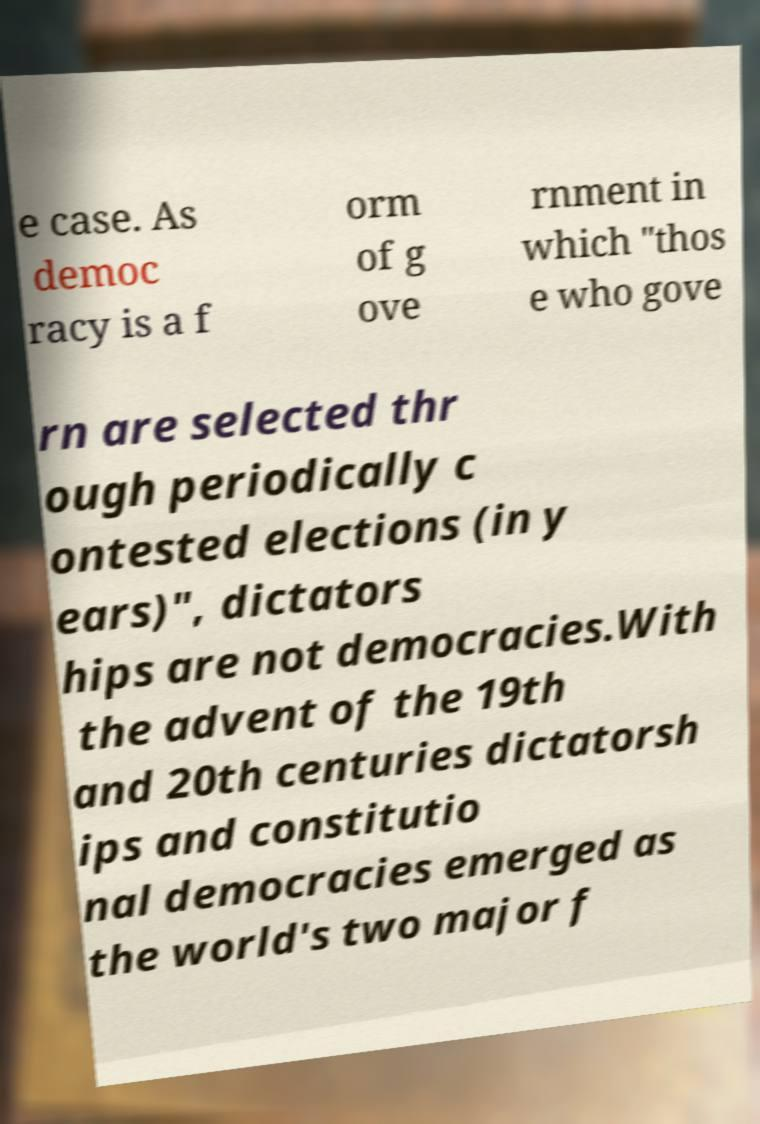Could you assist in decoding the text presented in this image and type it out clearly? e case. As democ racy is a f orm of g ove rnment in which "thos e who gove rn are selected thr ough periodically c ontested elections (in y ears)", dictators hips are not democracies.With the advent of the 19th and 20th centuries dictatorsh ips and constitutio nal democracies emerged as the world's two major f 